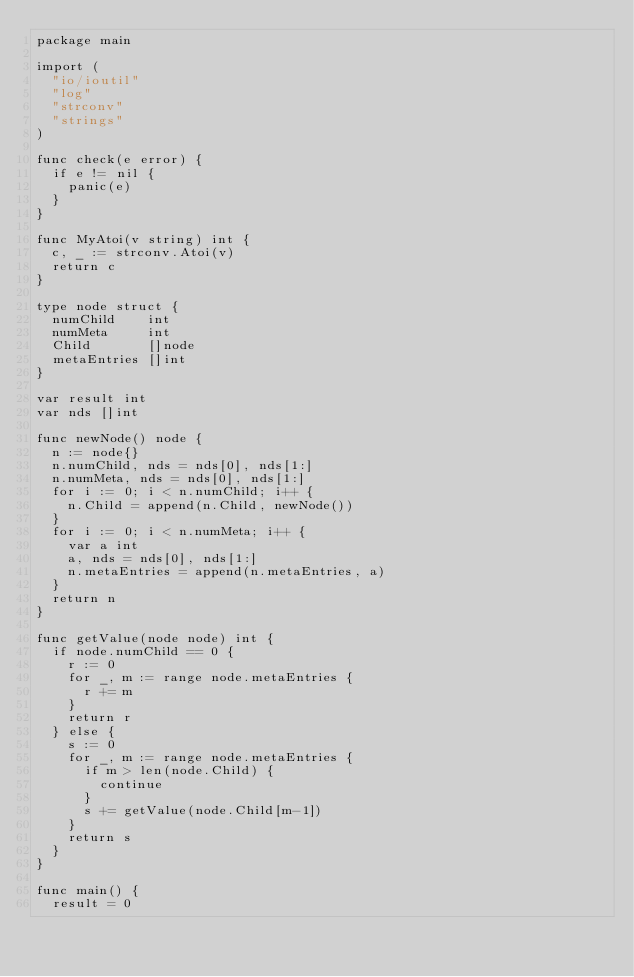<code> <loc_0><loc_0><loc_500><loc_500><_Go_>package main

import (
	"io/ioutil"
	"log"
	"strconv"
	"strings"
)

func check(e error) {
	if e != nil {
		panic(e)
	}
}

func MyAtoi(v string) int {
	c, _ := strconv.Atoi(v)
	return c
}

type node struct {
	numChild    int
	numMeta     int
	Child       []node
	metaEntries []int
}

var result int
var nds []int

func newNode() node {
	n := node{}
	n.numChild, nds = nds[0], nds[1:]
	n.numMeta, nds = nds[0], nds[1:]
	for i := 0; i < n.numChild; i++ {
		n.Child = append(n.Child, newNode())
	}
	for i := 0; i < n.numMeta; i++ {
		var a int
		a, nds = nds[0], nds[1:]
		n.metaEntries = append(n.metaEntries, a)
	}
	return n
}

func getValue(node node) int {
	if node.numChild == 0 {
		r := 0
		for _, m := range node.metaEntries {
			r += m
		}
		return r
	} else {
		s := 0
		for _, m := range node.metaEntries {
			if m > len(node.Child) {
				continue
			}
			s += getValue(node.Child[m-1])
		}
		return s
	}
}

func main() {
	result = 0</code> 